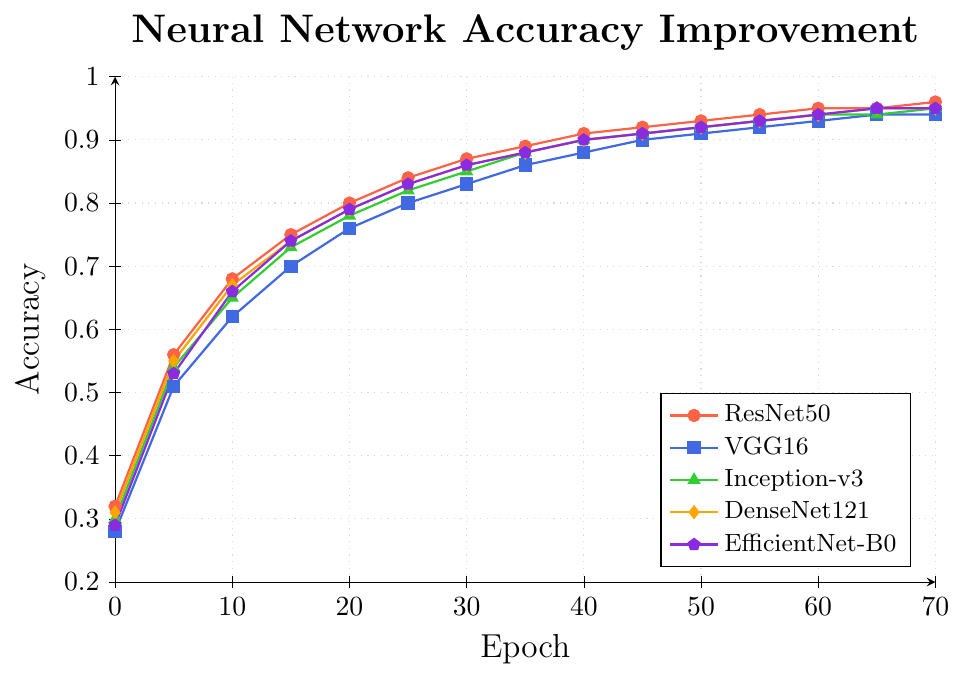Which neural network architecture shows the highest accuracy at the end of the training epochs? At epoch 70, ResNet50 shows the highest accuracy line reaching 0.96.
Answer: ResNet50 How does the accuracy of VGG16 compare to DenseNet121 at epoch 25? At epoch 25, VGG16 has an accuracy of 0.80, while DenseNet121 has an accuracy of 0.83. So, DenseNet121 is higher.
Answer: DenseNet121 is higher What are the visual attributes of the Inception-v3 plot line? The Inception-v3 plot line is green and marked with triangles throughout the figure.
Answer: Green and triangle markers Which architecture shows the most significant improvement in accuracy from epoch 0 to epoch 10? ResNet50 improves from 0.32 to 0.68, a difference of 0.36. VGG16 improves from 0.28 to 0.62, an increase of 0.34. Inception-v3 improves from 0.30 to 0.65, which is 0.35. DenseNet121 improves from 0.31 to 0.67, an increase of 0.36. EfficientNet-B0 improves from 0.29 to 0.66, a difference of 0.37. Therefore, the most significant improvement is EfficientNet-B0.
Answer: EfficientNet-B0 At which epochs do ResNet50 and EfficientNet-B0 share the same accuracy? ResNet50 and EfficientNet-B0 share the same accuracy of 0.95 at epochs 65 and 70.
Answer: Epochs 65 and 70 What's the comparison of all architectures' accuracy at epoch 40? At epoch 40, the accuracies are: ResNet50: 0.91, VGG16: 0.88, Inception-v3: 0.90, DenseNet121: 0.90, EfficientNet-B0: 0.90. ResNet50 shows the highest accuracy, while VGG16 has the lowest.
Answer: ResNet50 highest, VGG16 lowest What is the average accuracy of DenseNet121 architecture from epoch 0 to epoch 70? Summing up all the values for DenseNet121 and dividing by the number of epochs: (0.31 + 0.55 + 0.67 + 0.74 + 0.79 + 0.83 + 0.86 + 0.88 + 0.90 + 0.91 + 0.92 + 0.93 + 0.94 + 0.95 + 0.95) / 15 = 12.83 / 15 = 0.855.
Answer: 0.855 How much higher is ResNet50's accuracy than VGG16 at epoch 50? At epoch 50, ResNet50 has an accuracy of 0.93 and VGG16 has an accuracy of 0.91. The difference is 0.93 - 0.91 = 0.02.
Answer: 0.02 